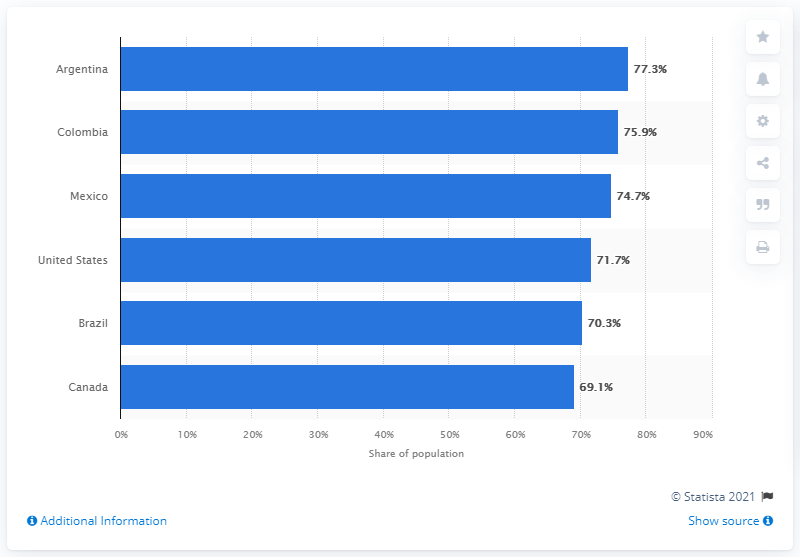Specify some key components in this picture. Argentina had the highest usage of Facebook among all countries. In April 2021, 71.7% of the U.S. population used Facebook, according to recent data. 